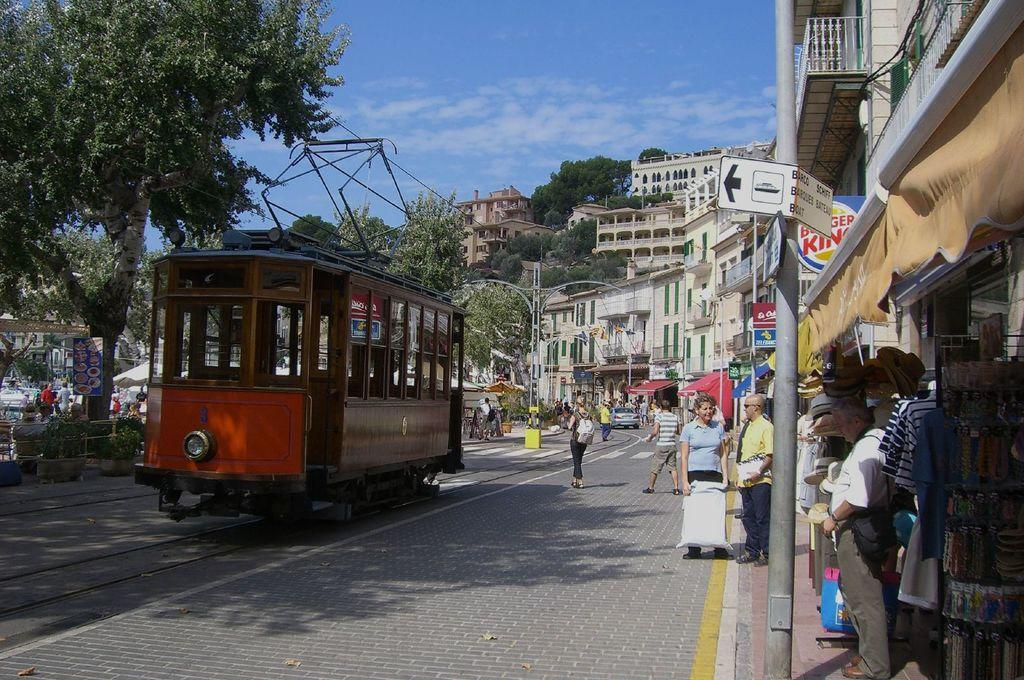<image>
Offer a succinct explanation of the picture presented. a trolly parked on the track in the street in front of burger king 